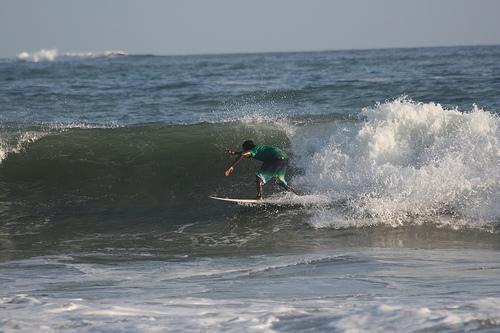How many people are in the photo?
Give a very brief answer. 1. 